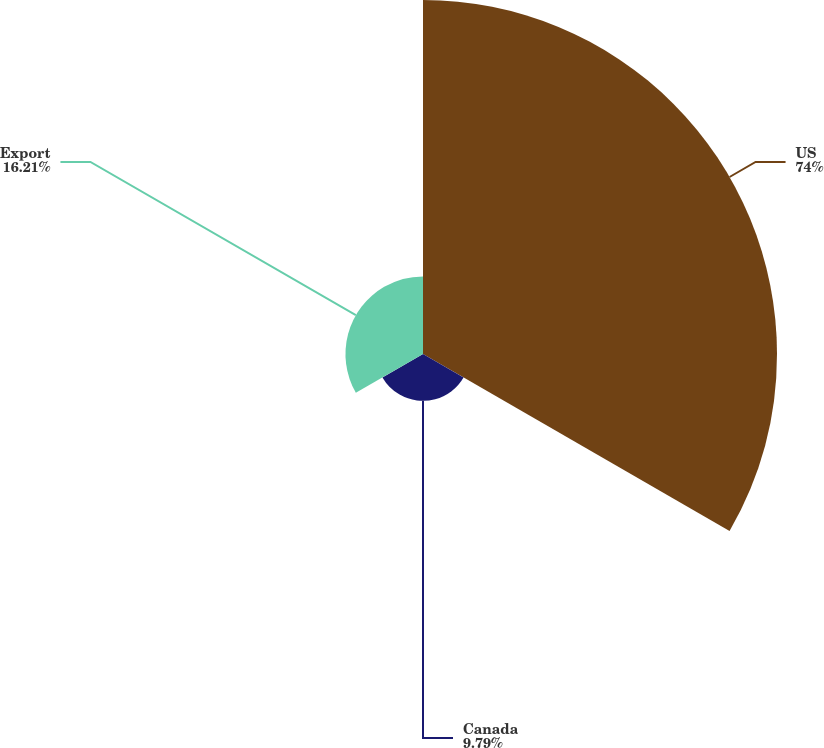<chart> <loc_0><loc_0><loc_500><loc_500><pie_chart><fcel>US<fcel>Canada<fcel>Export<nl><fcel>74.0%<fcel>9.79%<fcel>16.21%<nl></chart> 